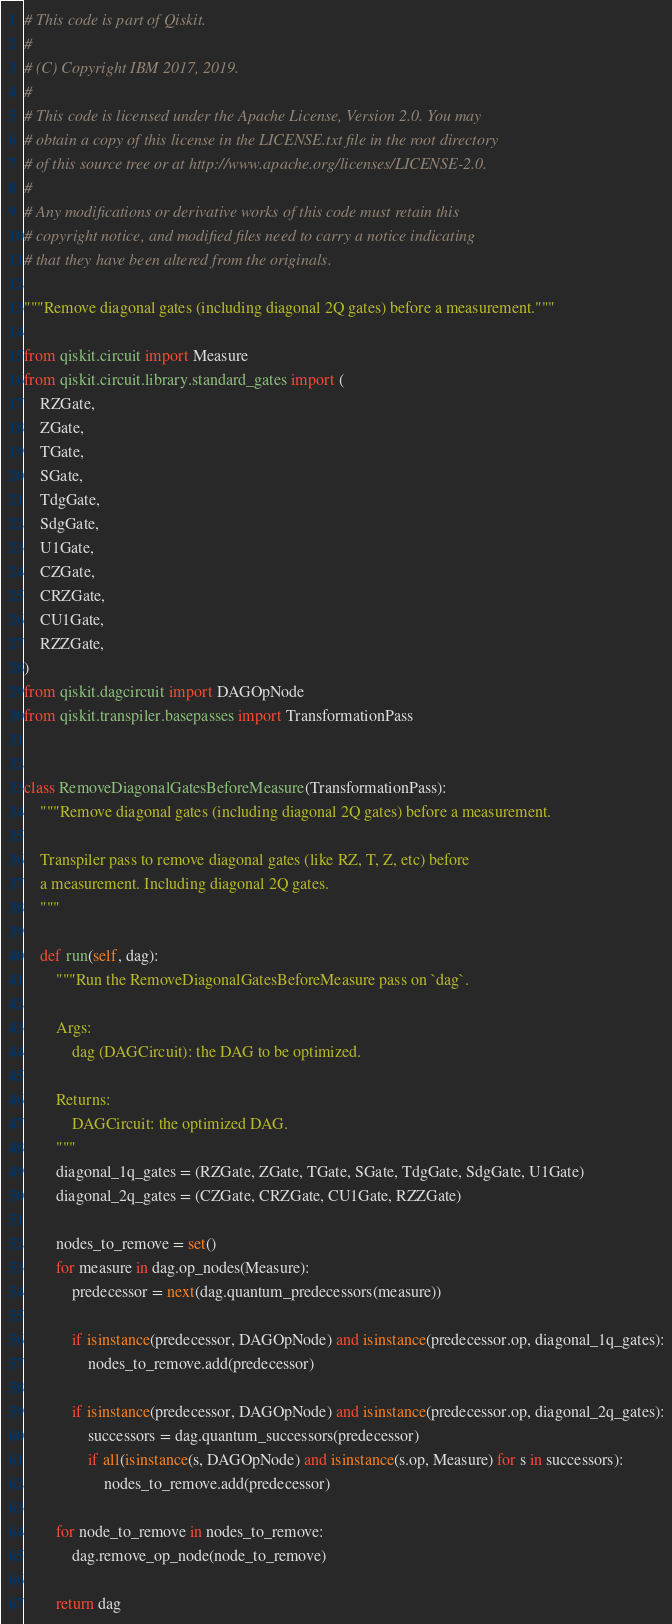Convert code to text. <code><loc_0><loc_0><loc_500><loc_500><_Python_># This code is part of Qiskit.
#
# (C) Copyright IBM 2017, 2019.
#
# This code is licensed under the Apache License, Version 2.0. You may
# obtain a copy of this license in the LICENSE.txt file in the root directory
# of this source tree or at http://www.apache.org/licenses/LICENSE-2.0.
#
# Any modifications or derivative works of this code must retain this
# copyright notice, and modified files need to carry a notice indicating
# that they have been altered from the originals.

"""Remove diagonal gates (including diagonal 2Q gates) before a measurement."""

from qiskit.circuit import Measure
from qiskit.circuit.library.standard_gates import (
    RZGate,
    ZGate,
    TGate,
    SGate,
    TdgGate,
    SdgGate,
    U1Gate,
    CZGate,
    CRZGate,
    CU1Gate,
    RZZGate,
)
from qiskit.dagcircuit import DAGOpNode
from qiskit.transpiler.basepasses import TransformationPass


class RemoveDiagonalGatesBeforeMeasure(TransformationPass):
    """Remove diagonal gates (including diagonal 2Q gates) before a measurement.

    Transpiler pass to remove diagonal gates (like RZ, T, Z, etc) before
    a measurement. Including diagonal 2Q gates.
    """

    def run(self, dag):
        """Run the RemoveDiagonalGatesBeforeMeasure pass on `dag`.

        Args:
            dag (DAGCircuit): the DAG to be optimized.

        Returns:
            DAGCircuit: the optimized DAG.
        """
        diagonal_1q_gates = (RZGate, ZGate, TGate, SGate, TdgGate, SdgGate, U1Gate)
        diagonal_2q_gates = (CZGate, CRZGate, CU1Gate, RZZGate)

        nodes_to_remove = set()
        for measure in dag.op_nodes(Measure):
            predecessor = next(dag.quantum_predecessors(measure))

            if isinstance(predecessor, DAGOpNode) and isinstance(predecessor.op, diagonal_1q_gates):
                nodes_to_remove.add(predecessor)

            if isinstance(predecessor, DAGOpNode) and isinstance(predecessor.op, diagonal_2q_gates):
                successors = dag.quantum_successors(predecessor)
                if all(isinstance(s, DAGOpNode) and isinstance(s.op, Measure) for s in successors):
                    nodes_to_remove.add(predecessor)

        for node_to_remove in nodes_to_remove:
            dag.remove_op_node(node_to_remove)

        return dag
</code> 